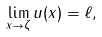<formula> <loc_0><loc_0><loc_500><loc_500>\lim _ { x \to \zeta } u ( x ) = \ell ,</formula> 